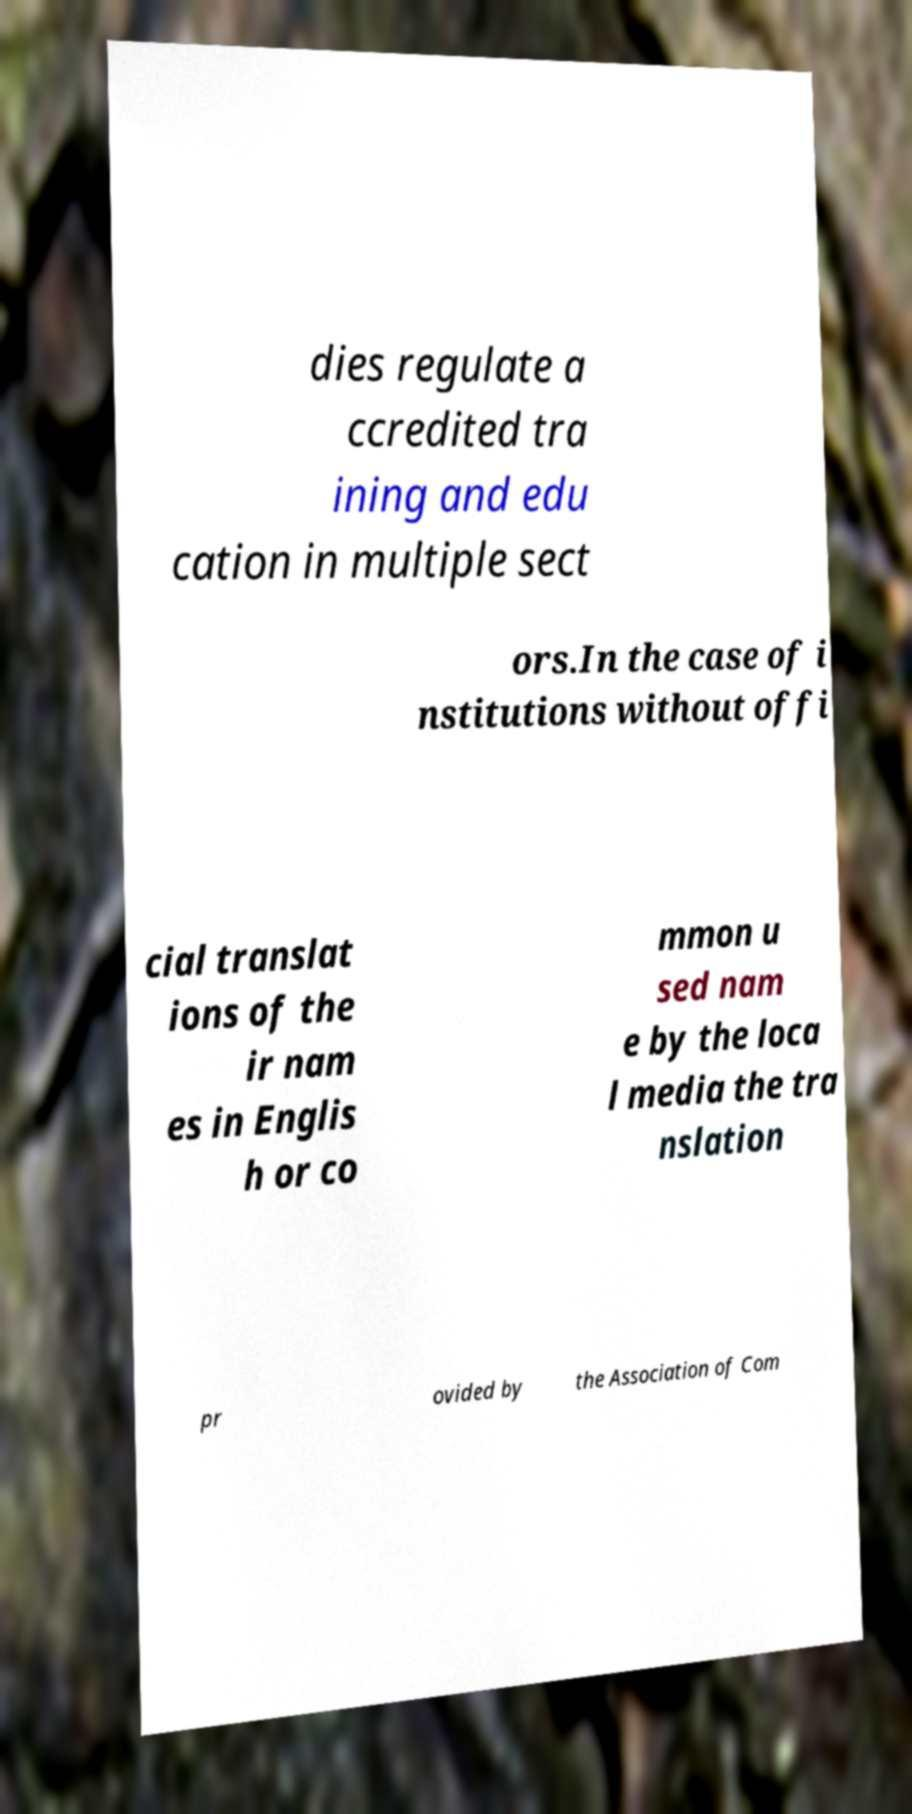Could you extract and type out the text from this image? dies regulate a ccredited tra ining and edu cation in multiple sect ors.In the case of i nstitutions without offi cial translat ions of the ir nam es in Englis h or co mmon u sed nam e by the loca l media the tra nslation pr ovided by the Association of Com 